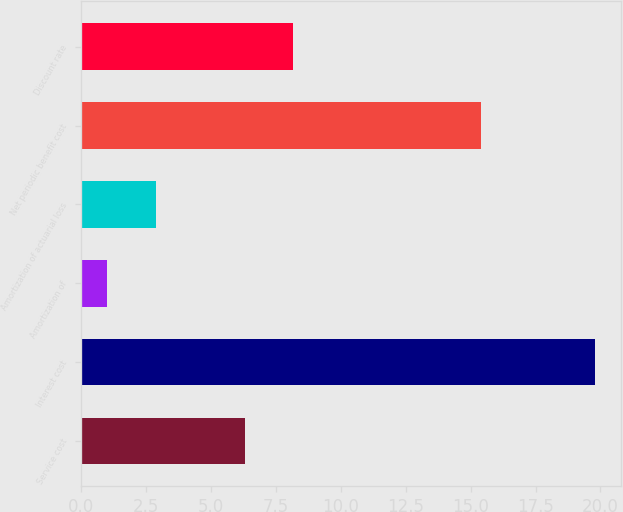Convert chart to OTSL. <chart><loc_0><loc_0><loc_500><loc_500><bar_chart><fcel>Service cost<fcel>Interest cost<fcel>Amortization of<fcel>Amortization of actuarial loss<fcel>Net periodic benefit cost<fcel>Discount rate<nl><fcel>6.3<fcel>19.8<fcel>1<fcel>2.88<fcel>15.4<fcel>8.18<nl></chart> 